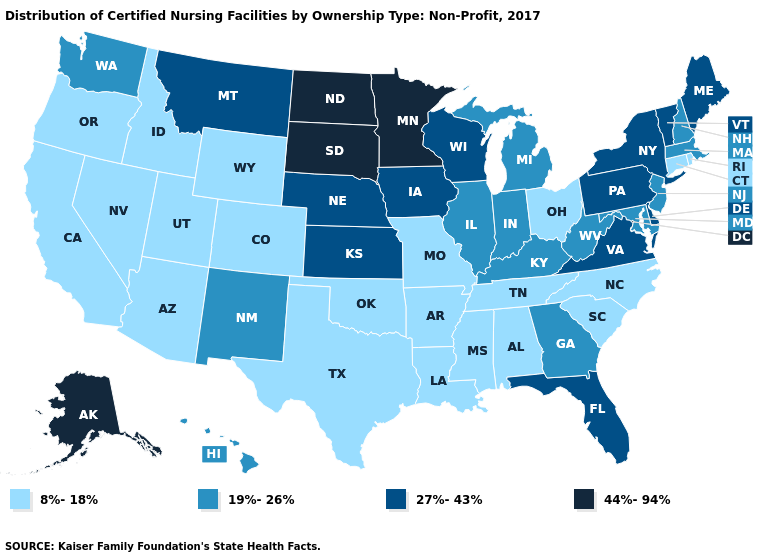What is the lowest value in the USA?
Give a very brief answer. 8%-18%. Name the states that have a value in the range 27%-43%?
Keep it brief. Delaware, Florida, Iowa, Kansas, Maine, Montana, Nebraska, New York, Pennsylvania, Vermont, Virginia, Wisconsin. What is the value of Hawaii?
Quick response, please. 19%-26%. Which states have the highest value in the USA?
Concise answer only. Alaska, Minnesota, North Dakota, South Dakota. Does Nevada have the same value as Louisiana?
Concise answer only. Yes. What is the highest value in the MidWest ?
Give a very brief answer. 44%-94%. What is the value of Indiana?
Be succinct. 19%-26%. What is the value of Minnesota?
Keep it brief. 44%-94%. Name the states that have a value in the range 8%-18%?
Be succinct. Alabama, Arizona, Arkansas, California, Colorado, Connecticut, Idaho, Louisiana, Mississippi, Missouri, Nevada, North Carolina, Ohio, Oklahoma, Oregon, Rhode Island, South Carolina, Tennessee, Texas, Utah, Wyoming. What is the lowest value in the West?
Give a very brief answer. 8%-18%. Does the map have missing data?
Concise answer only. No. What is the highest value in the USA?
Answer briefly. 44%-94%. Name the states that have a value in the range 44%-94%?
Keep it brief. Alaska, Minnesota, North Dakota, South Dakota. What is the lowest value in the USA?
Give a very brief answer. 8%-18%. Is the legend a continuous bar?
Keep it brief. No. 